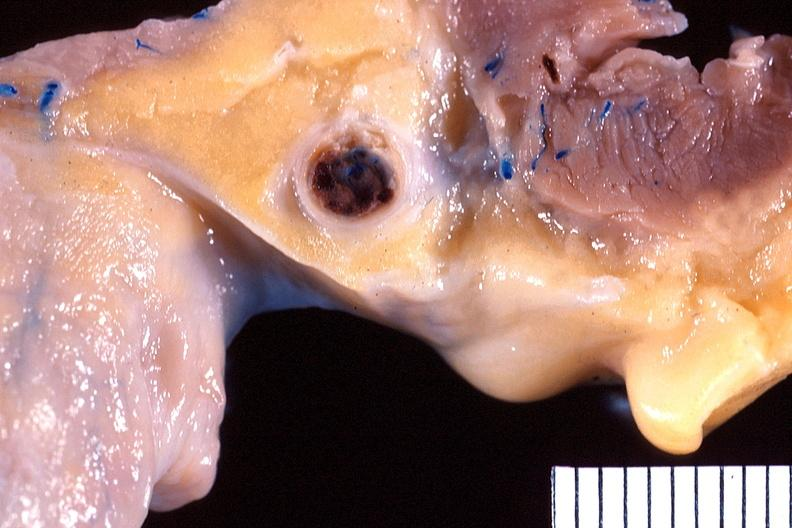s all the fat necrosis present?
Answer the question using a single word or phrase. No 